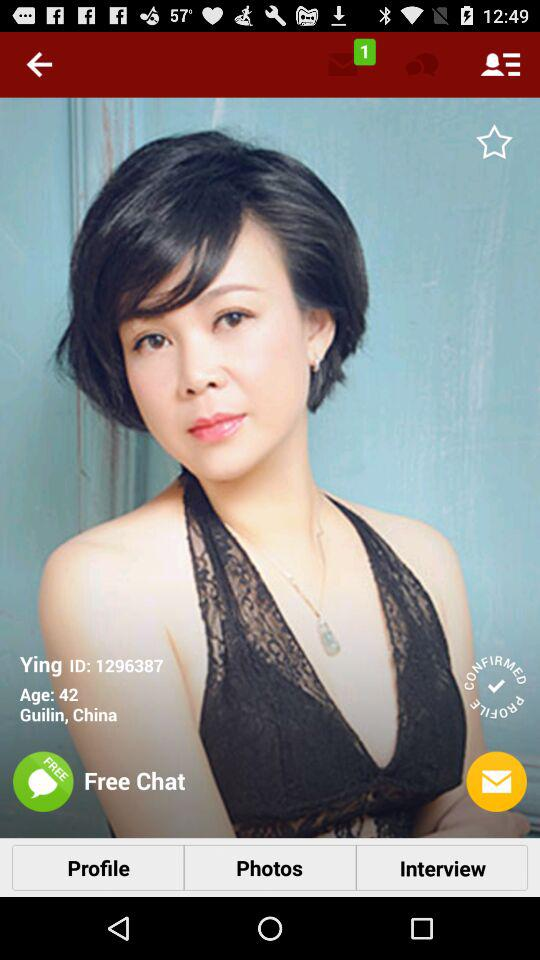What is the location? The location is Guilin, China. 